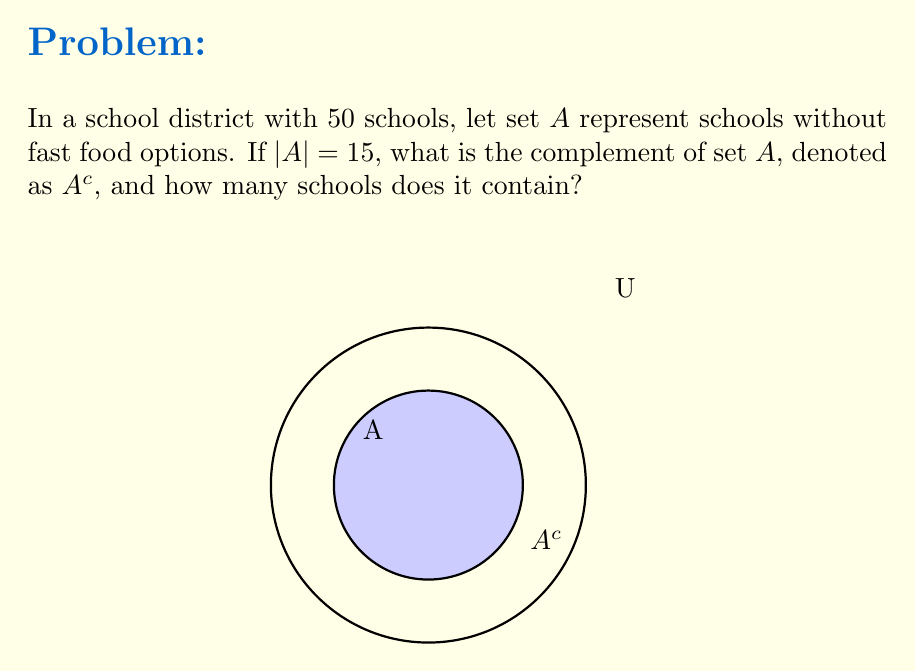Could you help me with this problem? Let's approach this step-by-step:

1) The universal set $U$ represents all schools in the district. We're given that $|U| = 50$.

2) Set $A$ represents schools without fast food options, and we're told that $|A| = 15$.

3) The complement of set $A$, denoted as $A^c$, represents all elements in the universal set that are not in $A$. In this context, $A^c$ represents schools that do have fast food options.

4) To find $A^c$, we use the formula:

   $|A^c| = |U| - |A|$

5) Substituting the values:

   $|A^c| = 50 - 15 = 35$

Therefore, $A^c$ contains 35 schools, which represents the number of schools with fast food options.
Answer: $A^c = \{schools\text{ with fast food options}\}$, $|A^c| = 35$ 